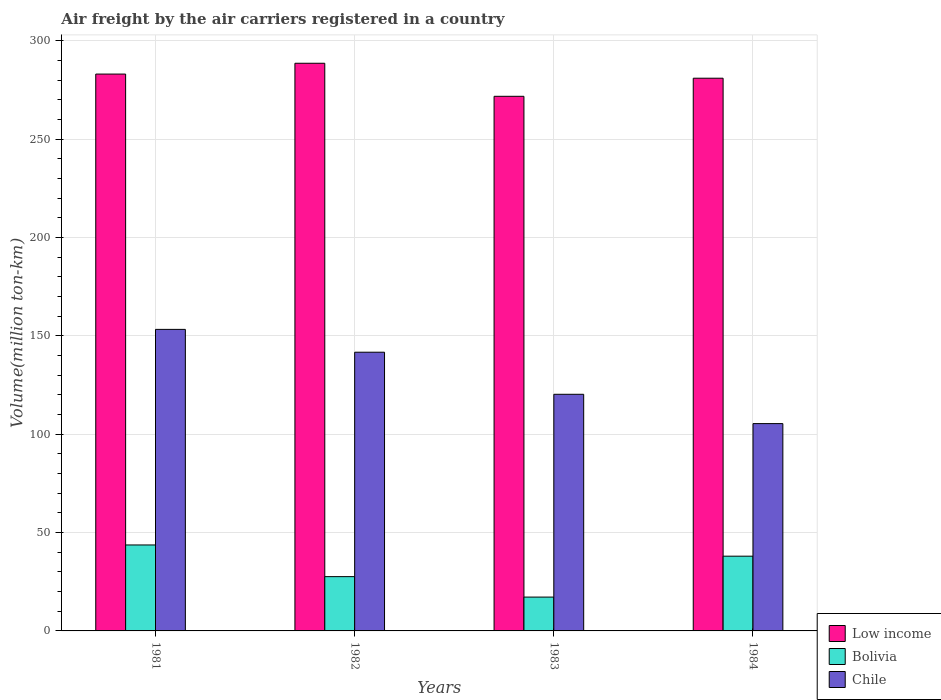How many different coloured bars are there?
Ensure brevity in your answer.  3. How many groups of bars are there?
Offer a very short reply. 4. Are the number of bars per tick equal to the number of legend labels?
Keep it short and to the point. Yes. How many bars are there on the 3rd tick from the right?
Provide a succinct answer. 3. What is the volume of the air carriers in Low income in 1981?
Your response must be concise. 283.1. Across all years, what is the maximum volume of the air carriers in Bolivia?
Offer a very short reply. 43.7. Across all years, what is the minimum volume of the air carriers in Bolivia?
Your answer should be very brief. 17.2. In which year was the volume of the air carriers in Bolivia minimum?
Ensure brevity in your answer.  1983. What is the total volume of the air carriers in Chile in the graph?
Offer a terse response. 520.7. What is the difference between the volume of the air carriers in Bolivia in 1982 and that in 1984?
Ensure brevity in your answer.  -10.4. What is the difference between the volume of the air carriers in Low income in 1982 and the volume of the air carriers in Bolivia in 1983?
Make the answer very short. 271.4. What is the average volume of the air carriers in Low income per year?
Provide a short and direct response. 281.12. In the year 1983, what is the difference between the volume of the air carriers in Chile and volume of the air carriers in Low income?
Give a very brief answer. -151.5. In how many years, is the volume of the air carriers in Bolivia greater than 280 million ton-km?
Ensure brevity in your answer.  0. What is the ratio of the volume of the air carriers in Low income in 1982 to that in 1984?
Make the answer very short. 1.03. Is the volume of the air carriers in Chile in 1983 less than that in 1984?
Ensure brevity in your answer.  No. Is the difference between the volume of the air carriers in Chile in 1983 and 1984 greater than the difference between the volume of the air carriers in Low income in 1983 and 1984?
Ensure brevity in your answer.  Yes. What is the difference between the highest and the second highest volume of the air carriers in Low income?
Offer a terse response. 5.5. What is the difference between the highest and the lowest volume of the air carriers in Bolivia?
Your response must be concise. 26.5. What does the 2nd bar from the left in 1981 represents?
Keep it short and to the point. Bolivia. Is it the case that in every year, the sum of the volume of the air carriers in Low income and volume of the air carriers in Chile is greater than the volume of the air carriers in Bolivia?
Ensure brevity in your answer.  Yes. Are all the bars in the graph horizontal?
Your answer should be compact. No. Are the values on the major ticks of Y-axis written in scientific E-notation?
Make the answer very short. No. Does the graph contain grids?
Offer a terse response. Yes. Where does the legend appear in the graph?
Offer a terse response. Bottom right. How are the legend labels stacked?
Keep it short and to the point. Vertical. What is the title of the graph?
Your answer should be compact. Air freight by the air carriers registered in a country. What is the label or title of the X-axis?
Provide a short and direct response. Years. What is the label or title of the Y-axis?
Offer a terse response. Volume(million ton-km). What is the Volume(million ton-km) of Low income in 1981?
Ensure brevity in your answer.  283.1. What is the Volume(million ton-km) of Bolivia in 1981?
Offer a terse response. 43.7. What is the Volume(million ton-km) of Chile in 1981?
Offer a very short reply. 153.3. What is the Volume(million ton-km) of Low income in 1982?
Offer a very short reply. 288.6. What is the Volume(million ton-km) of Bolivia in 1982?
Provide a short and direct response. 27.6. What is the Volume(million ton-km) of Chile in 1982?
Ensure brevity in your answer.  141.7. What is the Volume(million ton-km) in Low income in 1983?
Offer a terse response. 271.8. What is the Volume(million ton-km) in Bolivia in 1983?
Offer a terse response. 17.2. What is the Volume(million ton-km) in Chile in 1983?
Provide a succinct answer. 120.3. What is the Volume(million ton-km) of Low income in 1984?
Keep it short and to the point. 281. What is the Volume(million ton-km) of Bolivia in 1984?
Keep it short and to the point. 38. What is the Volume(million ton-km) in Chile in 1984?
Your answer should be compact. 105.4. Across all years, what is the maximum Volume(million ton-km) of Low income?
Your response must be concise. 288.6. Across all years, what is the maximum Volume(million ton-km) in Bolivia?
Your answer should be compact. 43.7. Across all years, what is the maximum Volume(million ton-km) of Chile?
Ensure brevity in your answer.  153.3. Across all years, what is the minimum Volume(million ton-km) of Low income?
Your answer should be very brief. 271.8. Across all years, what is the minimum Volume(million ton-km) in Bolivia?
Offer a very short reply. 17.2. Across all years, what is the minimum Volume(million ton-km) of Chile?
Keep it short and to the point. 105.4. What is the total Volume(million ton-km) of Low income in the graph?
Keep it short and to the point. 1124.5. What is the total Volume(million ton-km) in Bolivia in the graph?
Your answer should be compact. 126.5. What is the total Volume(million ton-km) of Chile in the graph?
Provide a short and direct response. 520.7. What is the difference between the Volume(million ton-km) in Low income in 1981 and that in 1982?
Keep it short and to the point. -5.5. What is the difference between the Volume(million ton-km) of Bolivia in 1981 and that in 1983?
Keep it short and to the point. 26.5. What is the difference between the Volume(million ton-km) of Chile in 1981 and that in 1983?
Provide a short and direct response. 33. What is the difference between the Volume(million ton-km) of Low income in 1981 and that in 1984?
Make the answer very short. 2.1. What is the difference between the Volume(million ton-km) in Chile in 1981 and that in 1984?
Ensure brevity in your answer.  47.9. What is the difference between the Volume(million ton-km) in Low income in 1982 and that in 1983?
Your answer should be compact. 16.8. What is the difference between the Volume(million ton-km) in Bolivia in 1982 and that in 1983?
Provide a short and direct response. 10.4. What is the difference between the Volume(million ton-km) of Chile in 1982 and that in 1983?
Keep it short and to the point. 21.4. What is the difference between the Volume(million ton-km) in Low income in 1982 and that in 1984?
Ensure brevity in your answer.  7.6. What is the difference between the Volume(million ton-km) in Chile in 1982 and that in 1984?
Offer a very short reply. 36.3. What is the difference between the Volume(million ton-km) in Bolivia in 1983 and that in 1984?
Provide a succinct answer. -20.8. What is the difference between the Volume(million ton-km) in Chile in 1983 and that in 1984?
Provide a short and direct response. 14.9. What is the difference between the Volume(million ton-km) of Low income in 1981 and the Volume(million ton-km) of Bolivia in 1982?
Your answer should be compact. 255.5. What is the difference between the Volume(million ton-km) in Low income in 1981 and the Volume(million ton-km) in Chile in 1982?
Offer a very short reply. 141.4. What is the difference between the Volume(million ton-km) of Bolivia in 1981 and the Volume(million ton-km) of Chile in 1982?
Your response must be concise. -98. What is the difference between the Volume(million ton-km) of Low income in 1981 and the Volume(million ton-km) of Bolivia in 1983?
Provide a succinct answer. 265.9. What is the difference between the Volume(million ton-km) in Low income in 1981 and the Volume(million ton-km) in Chile in 1983?
Provide a short and direct response. 162.8. What is the difference between the Volume(million ton-km) of Bolivia in 1981 and the Volume(million ton-km) of Chile in 1983?
Provide a succinct answer. -76.6. What is the difference between the Volume(million ton-km) of Low income in 1981 and the Volume(million ton-km) of Bolivia in 1984?
Provide a succinct answer. 245.1. What is the difference between the Volume(million ton-km) of Low income in 1981 and the Volume(million ton-km) of Chile in 1984?
Keep it short and to the point. 177.7. What is the difference between the Volume(million ton-km) of Bolivia in 1981 and the Volume(million ton-km) of Chile in 1984?
Your response must be concise. -61.7. What is the difference between the Volume(million ton-km) in Low income in 1982 and the Volume(million ton-km) in Bolivia in 1983?
Provide a succinct answer. 271.4. What is the difference between the Volume(million ton-km) of Low income in 1982 and the Volume(million ton-km) of Chile in 1983?
Ensure brevity in your answer.  168.3. What is the difference between the Volume(million ton-km) in Bolivia in 1982 and the Volume(million ton-km) in Chile in 1983?
Make the answer very short. -92.7. What is the difference between the Volume(million ton-km) in Low income in 1982 and the Volume(million ton-km) in Bolivia in 1984?
Your answer should be compact. 250.6. What is the difference between the Volume(million ton-km) of Low income in 1982 and the Volume(million ton-km) of Chile in 1984?
Make the answer very short. 183.2. What is the difference between the Volume(million ton-km) in Bolivia in 1982 and the Volume(million ton-km) in Chile in 1984?
Keep it short and to the point. -77.8. What is the difference between the Volume(million ton-km) in Low income in 1983 and the Volume(million ton-km) in Bolivia in 1984?
Offer a very short reply. 233.8. What is the difference between the Volume(million ton-km) of Low income in 1983 and the Volume(million ton-km) of Chile in 1984?
Provide a succinct answer. 166.4. What is the difference between the Volume(million ton-km) of Bolivia in 1983 and the Volume(million ton-km) of Chile in 1984?
Your answer should be very brief. -88.2. What is the average Volume(million ton-km) of Low income per year?
Make the answer very short. 281.12. What is the average Volume(million ton-km) in Bolivia per year?
Make the answer very short. 31.62. What is the average Volume(million ton-km) in Chile per year?
Your response must be concise. 130.18. In the year 1981, what is the difference between the Volume(million ton-km) of Low income and Volume(million ton-km) of Bolivia?
Provide a succinct answer. 239.4. In the year 1981, what is the difference between the Volume(million ton-km) in Low income and Volume(million ton-km) in Chile?
Offer a very short reply. 129.8. In the year 1981, what is the difference between the Volume(million ton-km) in Bolivia and Volume(million ton-km) in Chile?
Your response must be concise. -109.6. In the year 1982, what is the difference between the Volume(million ton-km) in Low income and Volume(million ton-km) in Bolivia?
Provide a succinct answer. 261. In the year 1982, what is the difference between the Volume(million ton-km) in Low income and Volume(million ton-km) in Chile?
Your response must be concise. 146.9. In the year 1982, what is the difference between the Volume(million ton-km) of Bolivia and Volume(million ton-km) of Chile?
Offer a very short reply. -114.1. In the year 1983, what is the difference between the Volume(million ton-km) of Low income and Volume(million ton-km) of Bolivia?
Keep it short and to the point. 254.6. In the year 1983, what is the difference between the Volume(million ton-km) of Low income and Volume(million ton-km) of Chile?
Provide a succinct answer. 151.5. In the year 1983, what is the difference between the Volume(million ton-km) in Bolivia and Volume(million ton-km) in Chile?
Provide a short and direct response. -103.1. In the year 1984, what is the difference between the Volume(million ton-km) of Low income and Volume(million ton-km) of Bolivia?
Provide a short and direct response. 243. In the year 1984, what is the difference between the Volume(million ton-km) of Low income and Volume(million ton-km) of Chile?
Provide a short and direct response. 175.6. In the year 1984, what is the difference between the Volume(million ton-km) in Bolivia and Volume(million ton-km) in Chile?
Your answer should be very brief. -67.4. What is the ratio of the Volume(million ton-km) of Low income in 1981 to that in 1982?
Give a very brief answer. 0.98. What is the ratio of the Volume(million ton-km) in Bolivia in 1981 to that in 1982?
Keep it short and to the point. 1.58. What is the ratio of the Volume(million ton-km) of Chile in 1981 to that in 1982?
Ensure brevity in your answer.  1.08. What is the ratio of the Volume(million ton-km) in Low income in 1981 to that in 1983?
Your answer should be compact. 1.04. What is the ratio of the Volume(million ton-km) in Bolivia in 1981 to that in 1983?
Ensure brevity in your answer.  2.54. What is the ratio of the Volume(million ton-km) in Chile in 1981 to that in 1983?
Provide a succinct answer. 1.27. What is the ratio of the Volume(million ton-km) of Low income in 1981 to that in 1984?
Your answer should be very brief. 1.01. What is the ratio of the Volume(million ton-km) in Bolivia in 1981 to that in 1984?
Ensure brevity in your answer.  1.15. What is the ratio of the Volume(million ton-km) in Chile in 1981 to that in 1984?
Keep it short and to the point. 1.45. What is the ratio of the Volume(million ton-km) in Low income in 1982 to that in 1983?
Offer a very short reply. 1.06. What is the ratio of the Volume(million ton-km) of Bolivia in 1982 to that in 1983?
Keep it short and to the point. 1.6. What is the ratio of the Volume(million ton-km) of Chile in 1982 to that in 1983?
Provide a succinct answer. 1.18. What is the ratio of the Volume(million ton-km) of Low income in 1982 to that in 1984?
Keep it short and to the point. 1.03. What is the ratio of the Volume(million ton-km) in Bolivia in 1982 to that in 1984?
Provide a short and direct response. 0.73. What is the ratio of the Volume(million ton-km) in Chile in 1982 to that in 1984?
Keep it short and to the point. 1.34. What is the ratio of the Volume(million ton-km) in Low income in 1983 to that in 1984?
Ensure brevity in your answer.  0.97. What is the ratio of the Volume(million ton-km) in Bolivia in 1983 to that in 1984?
Offer a very short reply. 0.45. What is the ratio of the Volume(million ton-km) of Chile in 1983 to that in 1984?
Your answer should be very brief. 1.14. What is the difference between the highest and the lowest Volume(million ton-km) of Low income?
Make the answer very short. 16.8. What is the difference between the highest and the lowest Volume(million ton-km) in Bolivia?
Give a very brief answer. 26.5. What is the difference between the highest and the lowest Volume(million ton-km) in Chile?
Keep it short and to the point. 47.9. 